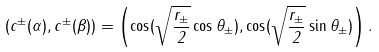Convert formula to latex. <formula><loc_0><loc_0><loc_500><loc_500>( c ^ { \pm } ( \alpha ) , c ^ { \pm } ( \beta ) ) = \left ( \cos ( \sqrt { \frac { r _ { \pm } } { 2 } } \cos \theta _ { \pm } ) , \cos ( \sqrt { \frac { r _ { \pm } } { 2 } } \sin \theta _ { \pm } ) \right ) .</formula> 